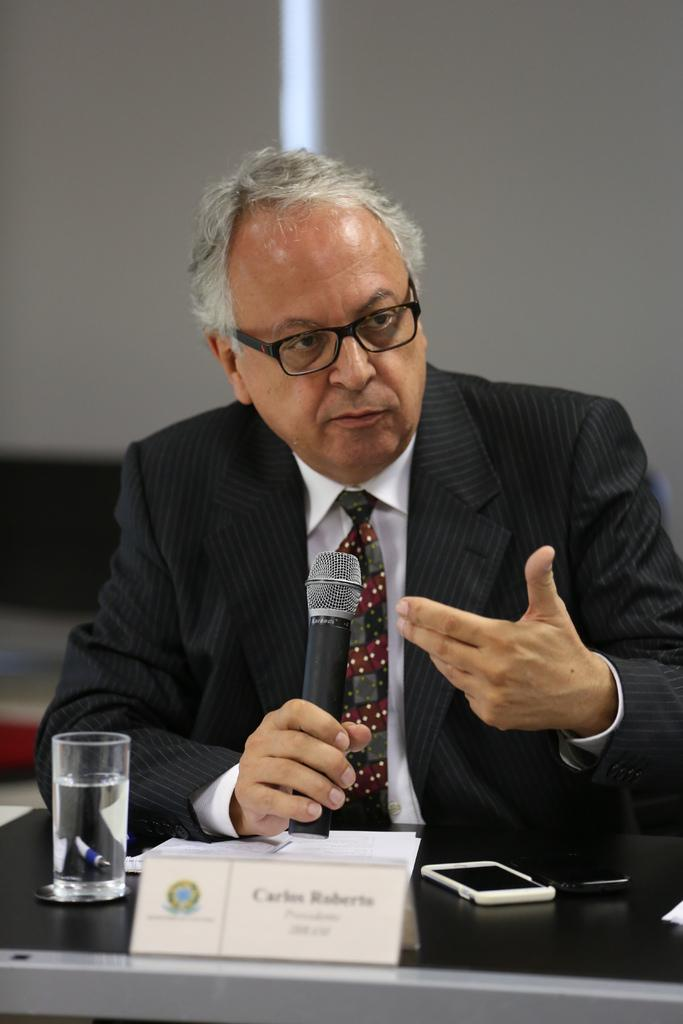What is the man holding in the image? The man is holding a microphone. What is the man doing with the microphone? The man is talking while holding the microphone. What can be seen on the table in the image? There is a mobile, papers, and a glass on the table. What is the man wearing in the image? The man is wearing a suit and spectacles. Can you see the river flowing behind the man in the image? There is no river visible in the image. 